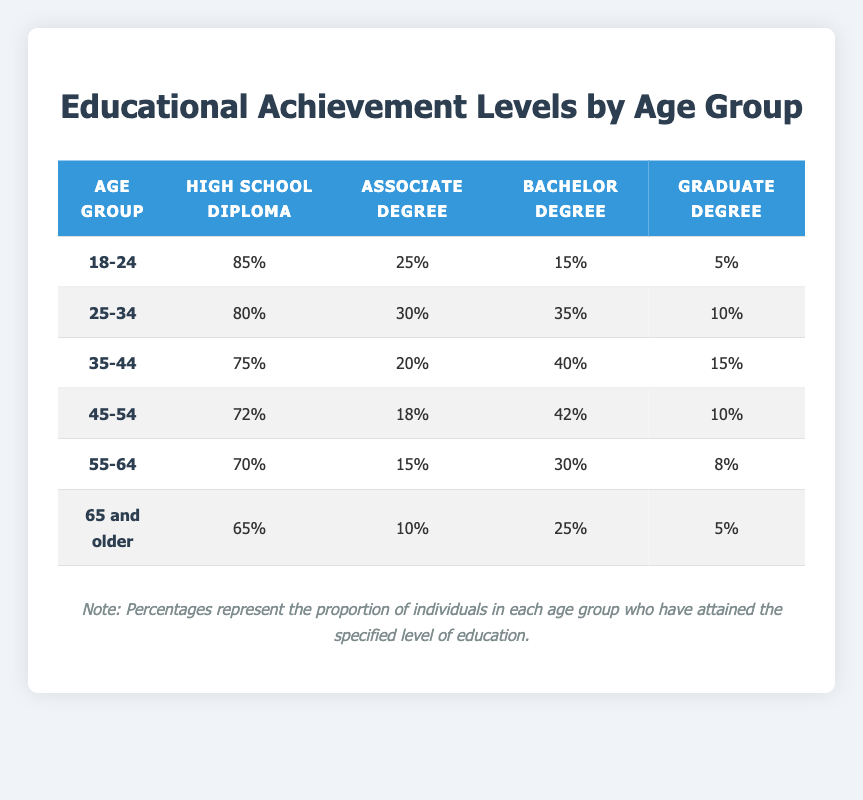What percentage of individuals aged 18-24 have a high school diploma? In the "18-24" age group row, the percentage of individuals with a high school diploma is directly listed as 85%.
Answer: 85% How many people in the 25-34 age group have at least a bachelor's degree? To find the total with at least a bachelor's degree, we add the percentages of individuals with a bachelor and graduate degree: 35% (Bachelor) + 10% (Graduate) = 45%.
Answer: 45% Is it true that individuals aged 65 and older have the highest percentage of high school diplomas among all age groups? Comparing the percentages of high school diplomas across all age groups, 65% in the "65 and older" group is lower than 85% in the "18-24" group, so it is not true.
Answer: No What is the average percentage of graduate degrees across all age groups? Adding the percentages of graduate degrees for all age groups: (5 + 10 + 15 + 10 + 8 + 5) = 53%. There are 6 age groups, so the average is 53% / 6 = 8.83%, rounded to 8.83%.
Answer: 8.83% Which age group has the highest percentage of individuals with an associate degree? In the table, the "25-34" age group has the highest percentage with 30% for an associate degree.
Answer: 30% What is the difference in percentages of bachelor degrees between the 35-44 and 45-54 age groups? The percentage of bachelor degrees in the "35-44" group is 40%, while in the "45-54" group it is 42%. The difference is 42% - 40% = 2%.
Answer: 2% How many age groups have more than 70% of individuals with a high school diploma? The age groups "18-24" (85%), "25-34" (80%), "35-44" (75%), and "45-54" (72%) have more than 70%. Counting them provides a total of 4 groups.
Answer: 4 What percentage of the 55-64 age group has less than a bachelor's degree? The 55-64 age group's percentages for high school and associate degrees are 70% and 15%, respectively. Adding these gives 70% + 15% = 85%.
Answer: 85% Which age group has the lowest proportion of graduate degrees? By looking at the table, the "18-24" group has the lowest percentage of graduate degrees at 5%.
Answer: 5% 